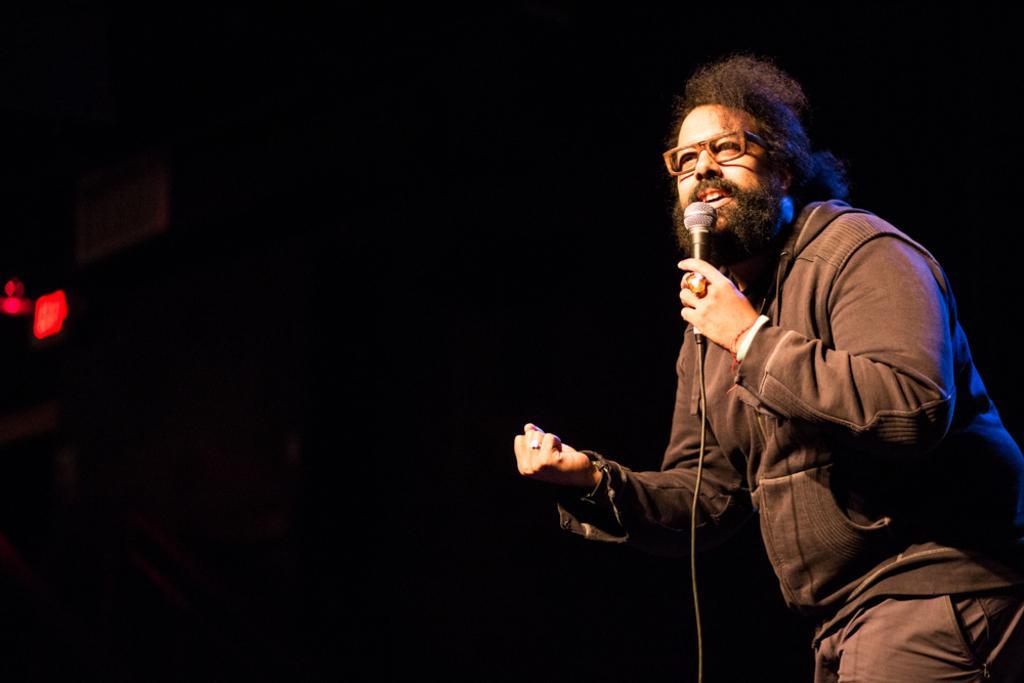Describe this image in one or two sentences. Here is a man standing and singing song holding a mike. He wore a jerkin,trouser and spectacles. At background it is so dark with a small red color light. 